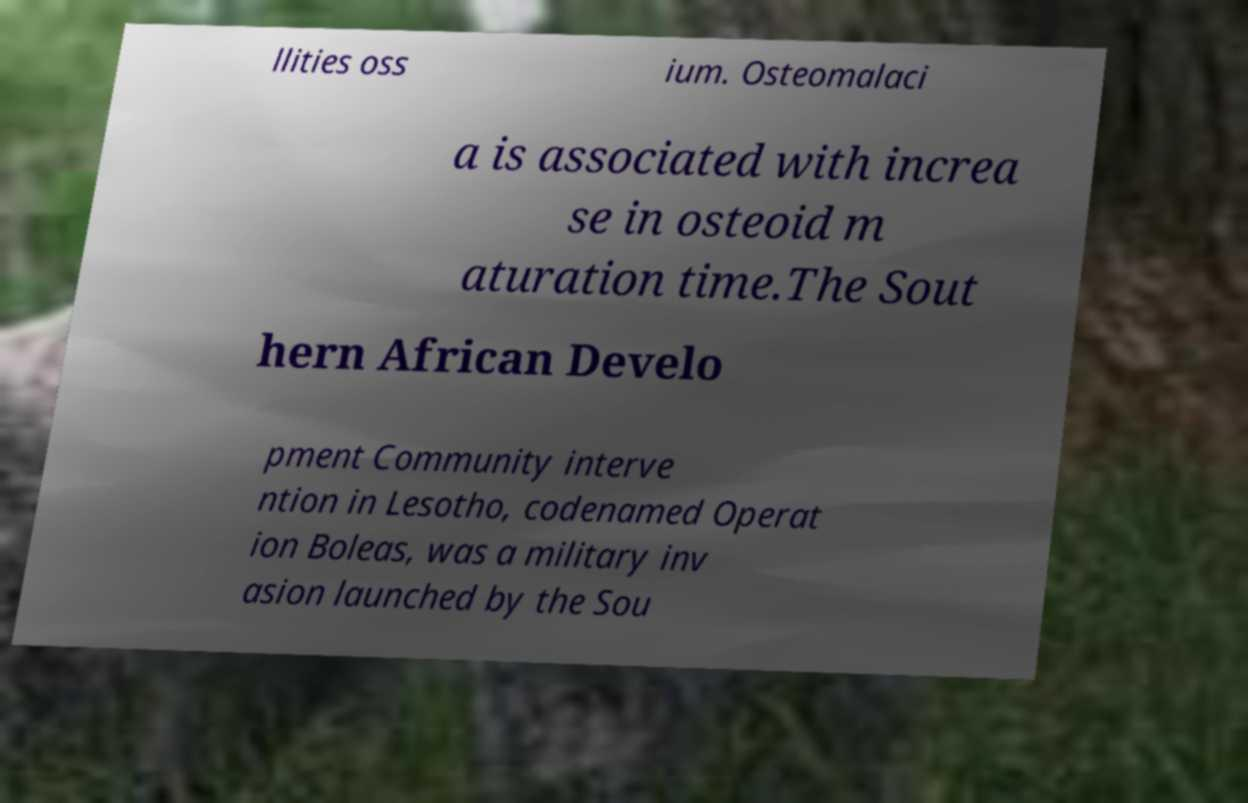Please read and relay the text visible in this image. What does it say? llities oss ium. Osteomalaci a is associated with increa se in osteoid m aturation time.The Sout hern African Develo pment Community interve ntion in Lesotho, codenamed Operat ion Boleas, was a military inv asion launched by the Sou 